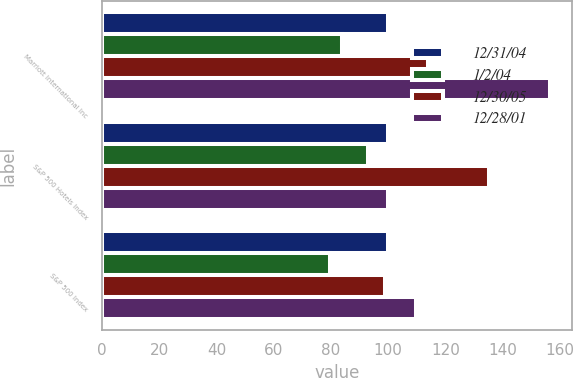<chart> <loc_0><loc_0><loc_500><loc_500><stacked_bar_chart><ecel><fcel>Marriott International Inc<fcel>S&P 500 Hotels Index<fcel>S&P 500 Index<nl><fcel>12/31/04<fcel>100<fcel>100<fcel>100<nl><fcel>1/2/04<fcel>84<fcel>92.8<fcel>79.6<nl><fcel>12/30/05<fcel>113.9<fcel>135.1<fcel>98.8<nl><fcel>12/28/01<fcel>156.4<fcel>100<fcel>109.9<nl></chart> 